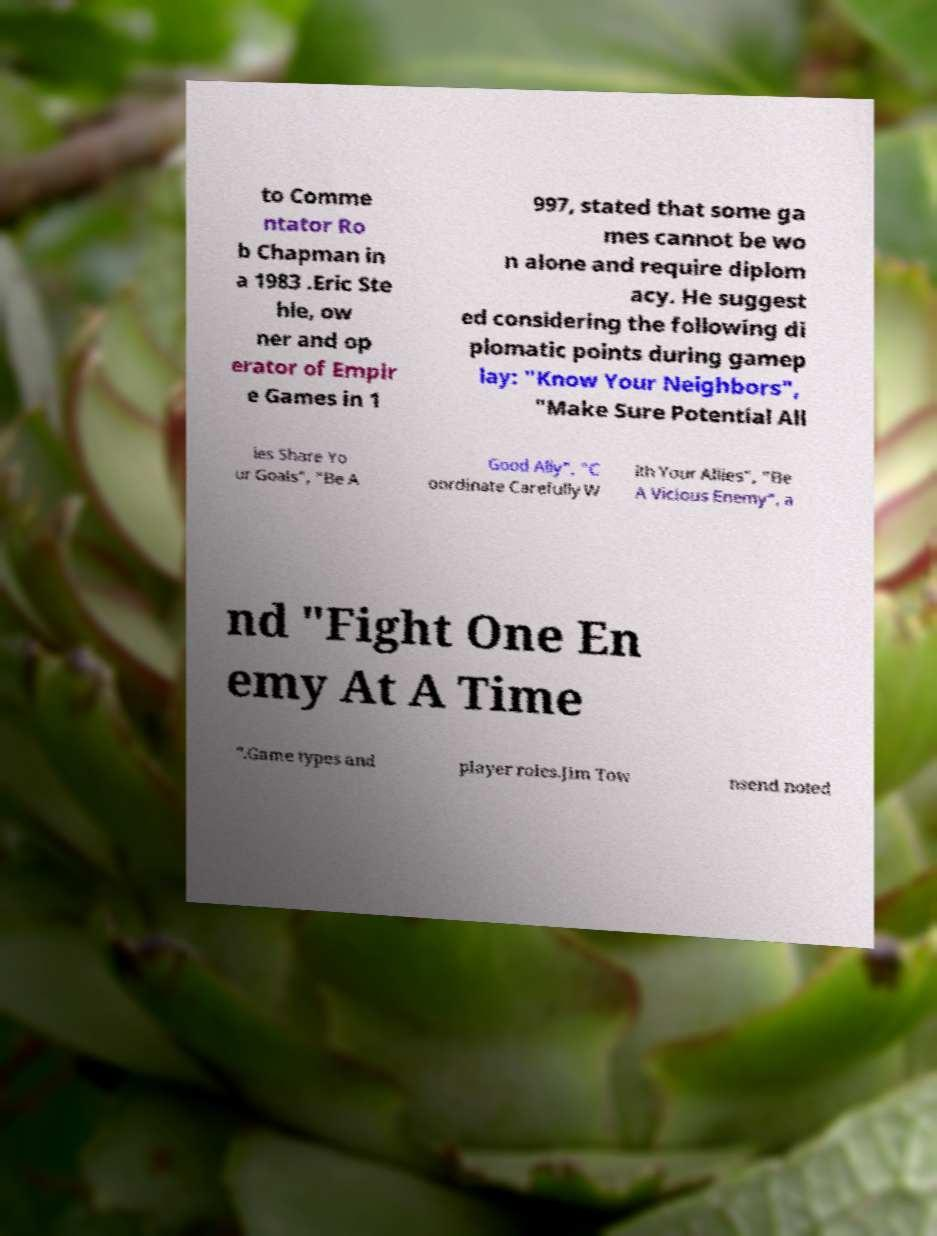There's text embedded in this image that I need extracted. Can you transcribe it verbatim? to Comme ntator Ro b Chapman in a 1983 .Eric Ste hle, ow ner and op erator of Empir e Games in 1 997, stated that some ga mes cannot be wo n alone and require diplom acy. He suggest ed considering the following di plomatic points during gamep lay: "Know Your Neighbors", "Make Sure Potential All ies Share Yo ur Goals", "Be A Good Ally", "C oordinate Carefully W ith Your Allies", "Be A Vicious Enemy", a nd "Fight One En emy At A Time ".Game types and player roles.Jim Tow nsend noted 